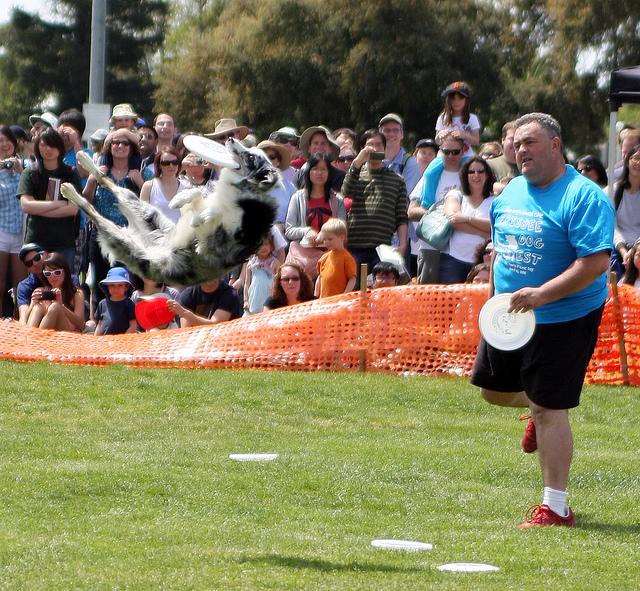What color shirt is the man wearing?
Quick response, please. Blue. Is this a professional event?
Keep it brief. Yes. What is the man holding?
Short answer required. Frisbee. 